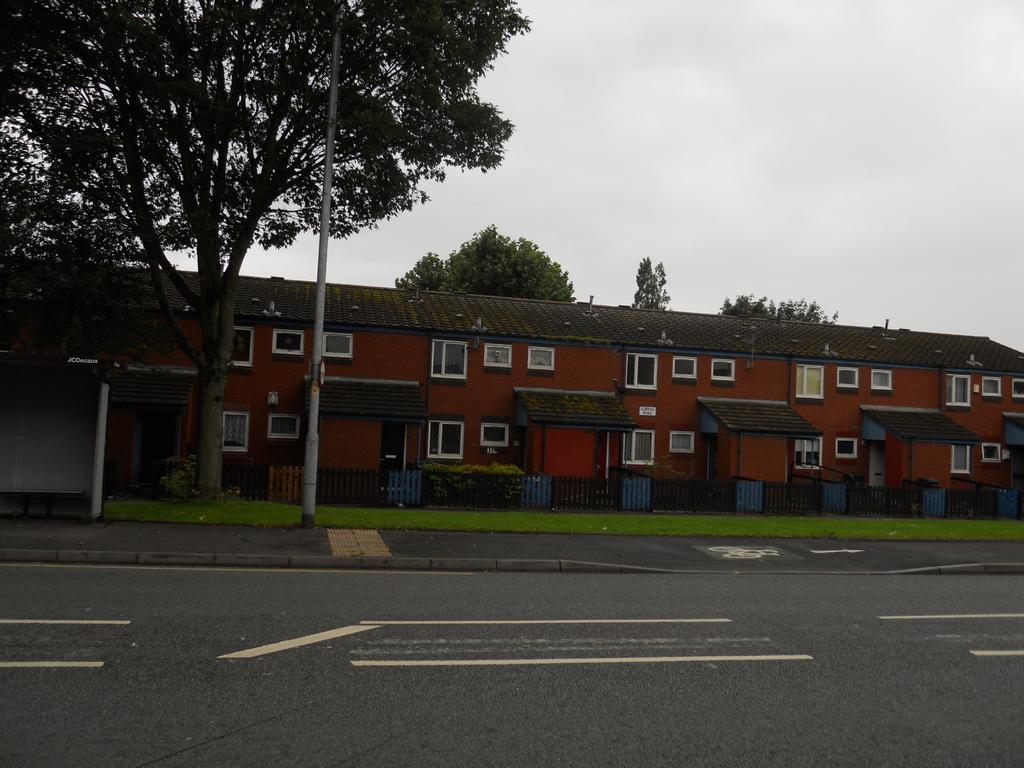Could you give a brief overview of what you see in this image? In this image in the background there are trees, there is a building and there is grass on the ground and there is a fence and the sky is cloudy. 